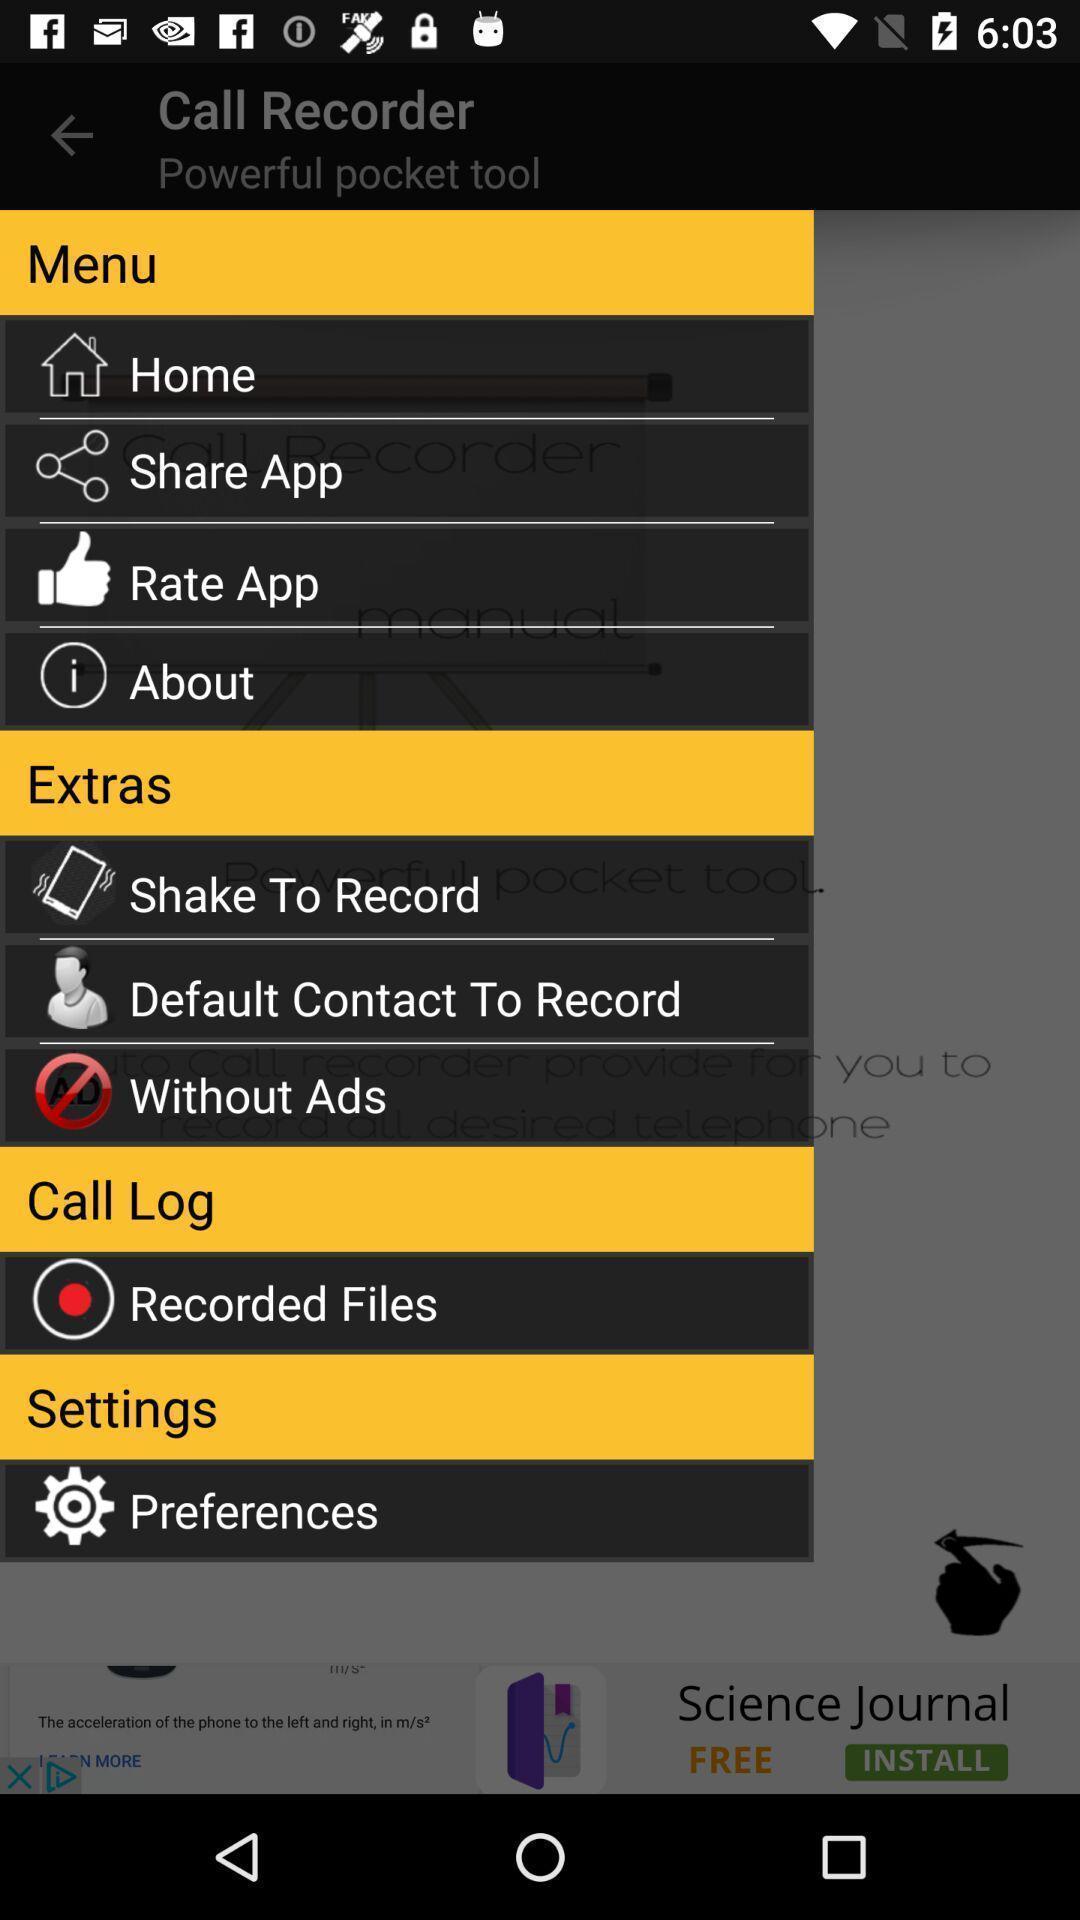Tell me what you see in this picture. Page displaying with options for the recording application. 